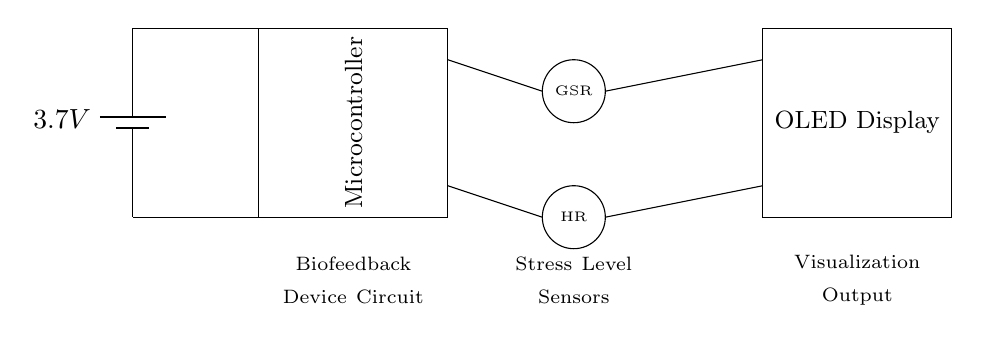What is the voltage of the power supply? The circuit has a battery labeled with a potential difference of 3.7 volts, indicating that is the voltage supplied to the rest of the components.
Answer: 3.7 volts What components are included in the circuit? Looking at the circuit diagram, there are three main components: a battery, a microcontroller, and sensors (GSR and HR), along with an OLED display for visualization.
Answer: Battery, microcontroller, sensors, OLED display Which sensors are used in this device? The circuit diagram shows two circular shapes with labels: one labeled GSR for Galvanic Skin Response and another labeled HR for Heart Rate. These indicate the types of sensors present in the device.
Answer: GSR and HR What is the output method for stress visualization? The output for visualizing stress levels is indicated by a rectangular shape labeled OLED Display, showing that it is the component responsible for presenting the processed data.
Answer: OLED Display How do the sensors connect to the microcontroller? The diagram shows lines leading from the sensors (GSR and HR) to the microcontroller, indicating they are connected directly to the microcontroller, which would process the sensor data.
Answer: Directly connected Why is a low voltage used for this biofeedback device? Low voltage, such as the 3.7 volts indicated, is typically used in portable biofeedback devices to ensure safety, extend battery life, and support lightweight design, making the device suitable for continuous use.
Answer: Safety and battery life 